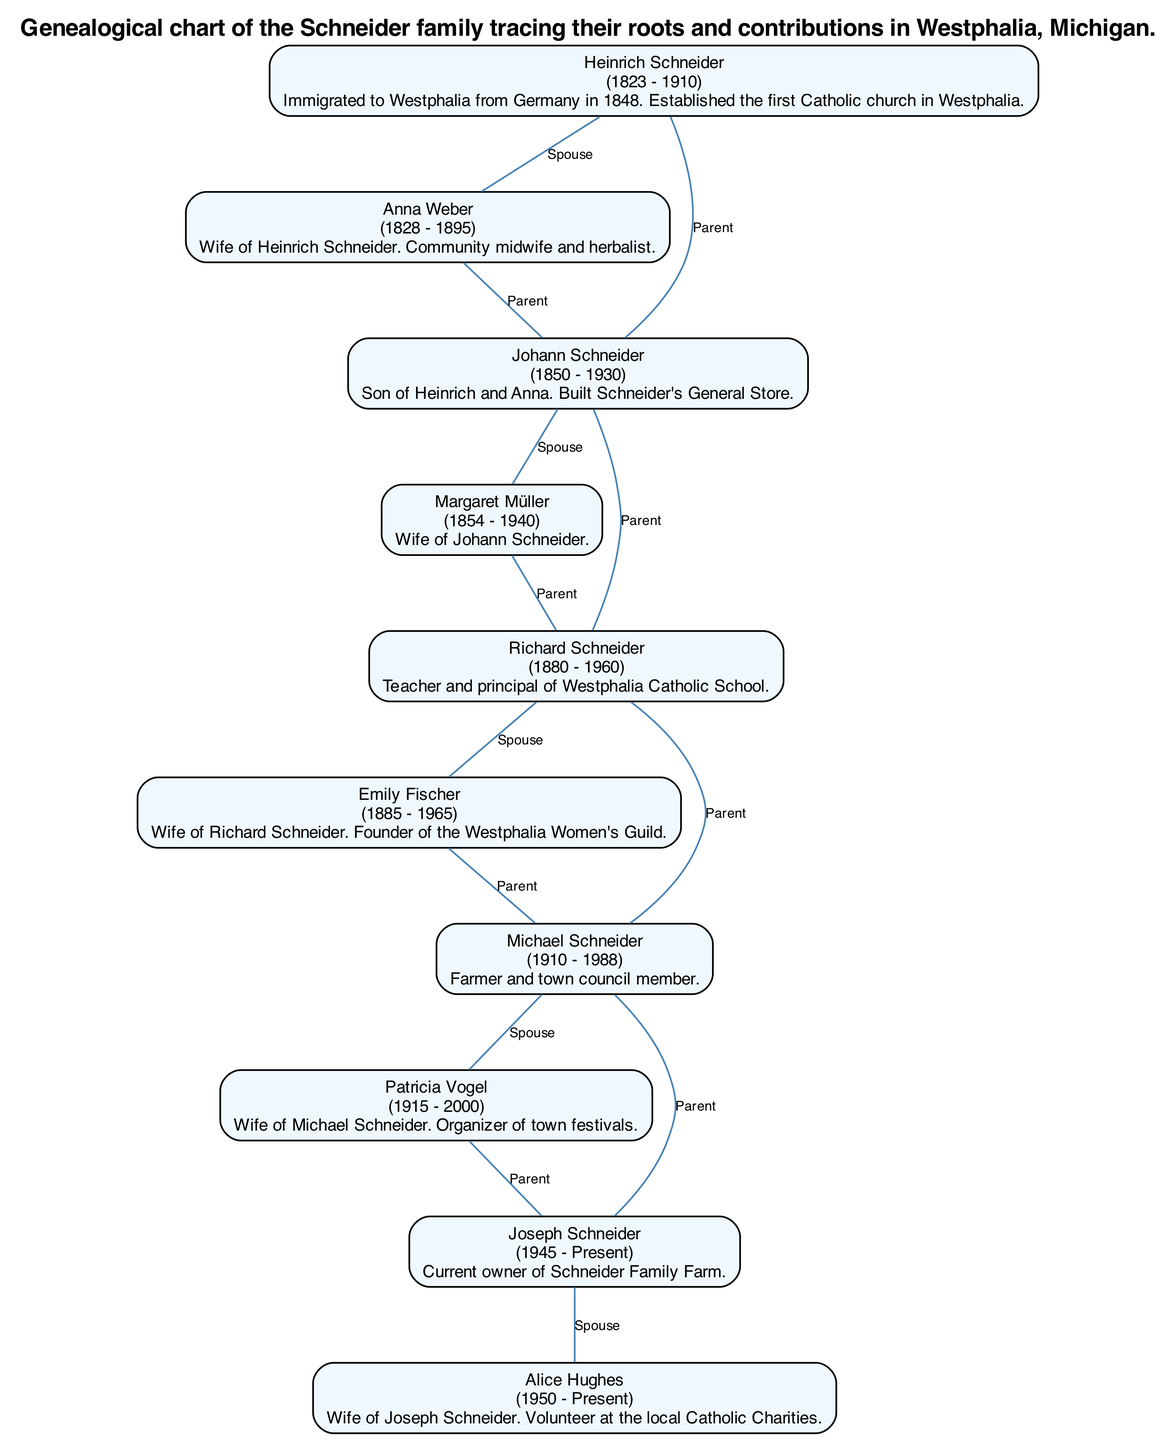What is the birth year of Heinrich Schneider? From the diagram, we can see that the node representing Heinrich Schneider states his birth year as 1823.
Answer: 1823 Who established the first Catholic church in Westphalia? The description for Heinrich Schneider indicates that he immigrated from Germany and established the first Catholic church in Westphalia.
Answer: Heinrich Schneider How many children did Johann Schneider have? The diagram shows that Johann Schneider is a parent to Richard Schneider and has no other children listed in the chart. Therefore, he has one child.
Answer: 1 What was Emily Fischer's role in the community? The node for Emily Fischer states that she is the founder of the Westphalia Women's Guild, highlighting her significant contribution.
Answer: Founder of the Westphalia Women's Guild Who is the current owner of Schneider Family Farm? According to the descriptions provided in the diagram, Joseph Schneider is noted as the current owner of Schneider Family Farm.
Answer: Joseph Schneider How many marriages are depicted in the family tree? By analyzing the diagram, we can count the relationship edges that represent marriages. There are four marriages among the members, connecting spouses to each other in the tree.
Answer: 4 Which family member was a town council member? From the description in the node for Michael Schneider, he is noted as both a farmer and a member of the town council, indicating his involvement in local governance.
Answer: Michael Schneider What year did Richard Schneider pass away? Referring to Richard Schneider's node, we can see that he died in 1960, which is directly stated in the information.
Answer: 1960 What community role did Patricia Vogel serve? The description provided in Patricia Vogel’s node mentions that she was the organizer of town festivals, which highlights her contributing role to community activities.
Answer: Organizer of town festivals 